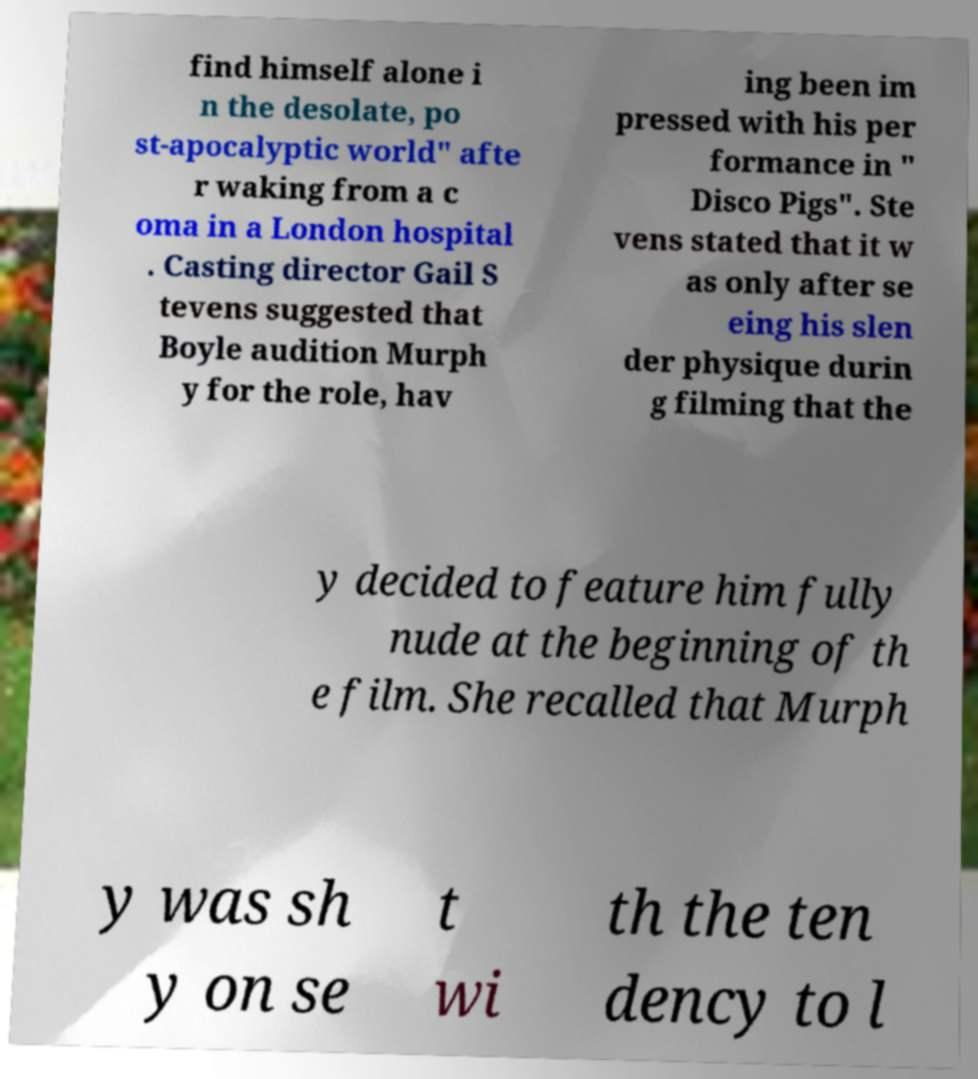Could you assist in decoding the text presented in this image and type it out clearly? find himself alone i n the desolate, po st-apocalyptic world" afte r waking from a c oma in a London hospital . Casting director Gail S tevens suggested that Boyle audition Murph y for the role, hav ing been im pressed with his per formance in " Disco Pigs". Ste vens stated that it w as only after se eing his slen der physique durin g filming that the y decided to feature him fully nude at the beginning of th e film. She recalled that Murph y was sh y on se t wi th the ten dency to l 